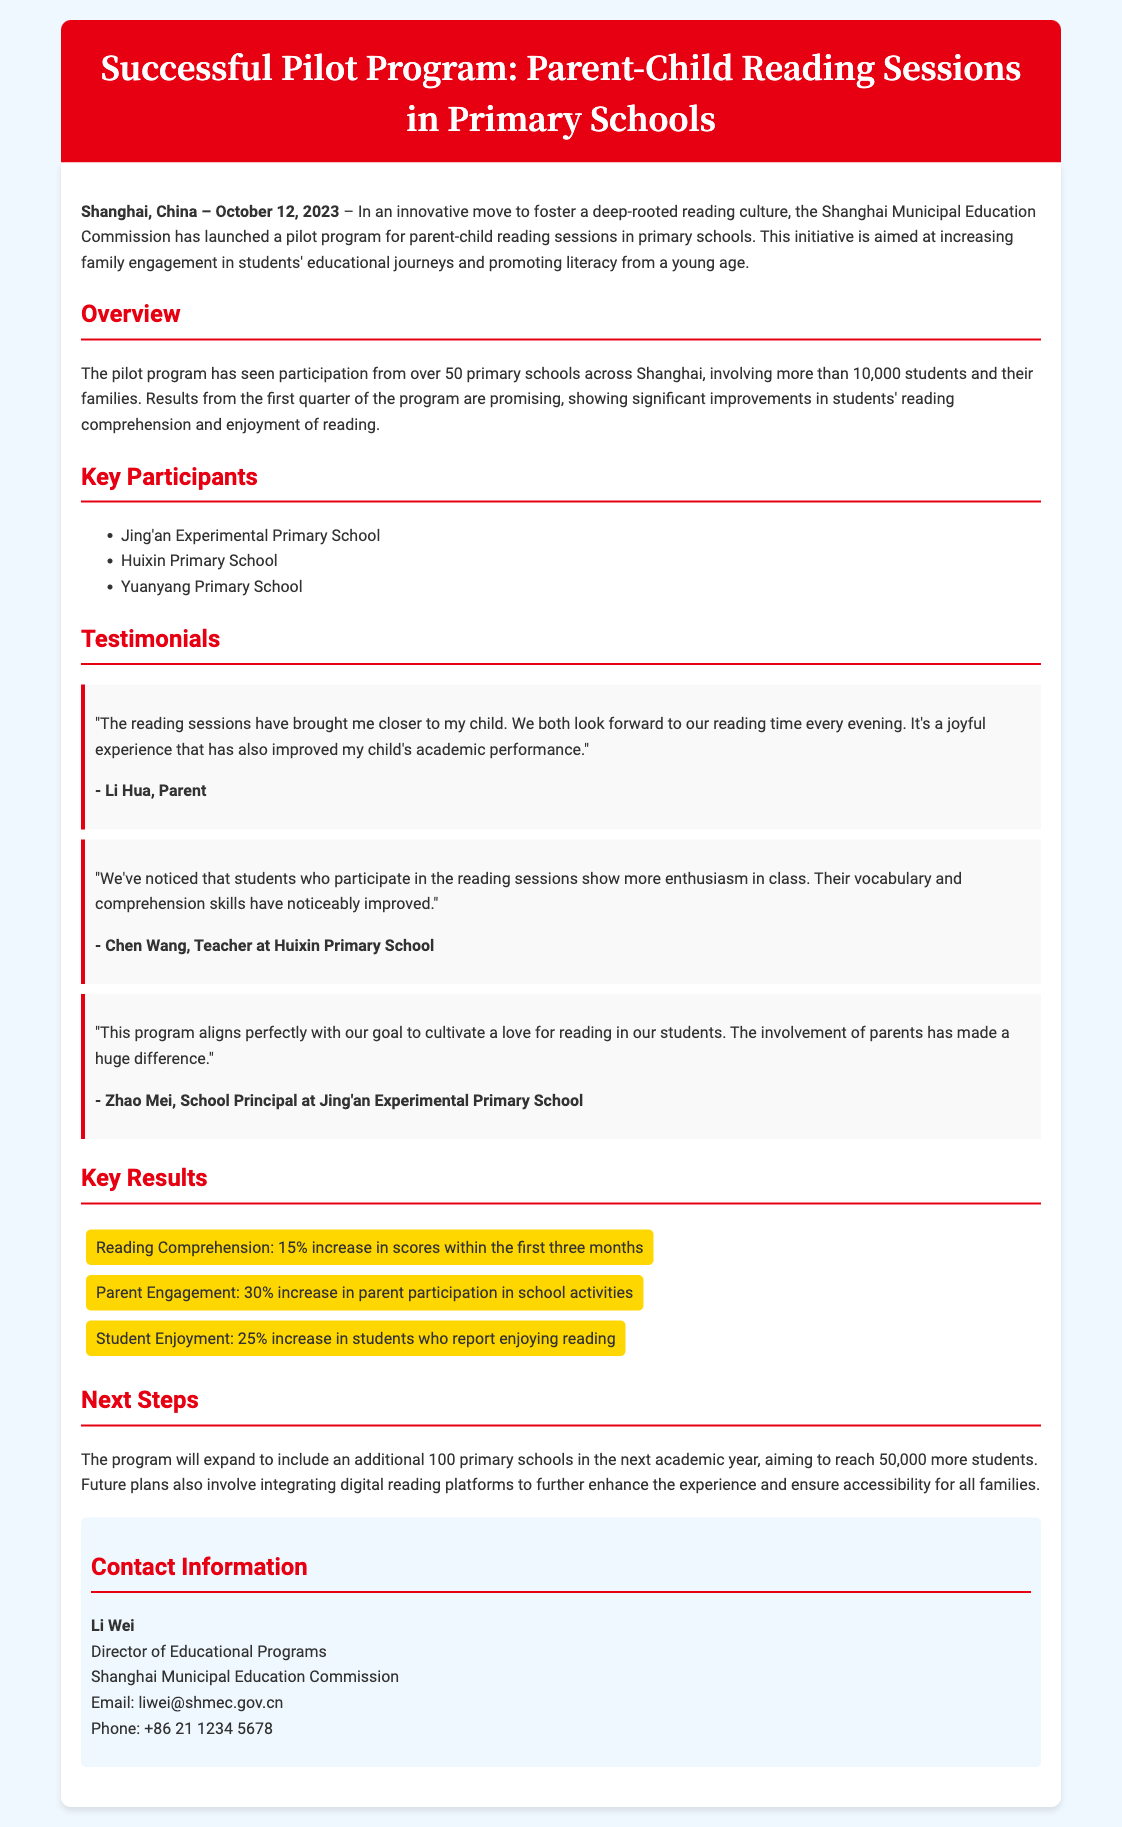What is the launch date of the program? The launch date mentioned in the document is October 12, 2023.
Answer: October 12, 2023 How many primary schools participated in the pilot program? The document states that over 50 primary schools across Shanghai participated in the pilot program.
Answer: Over 50 What percentage increase in reading comprehension was reported within the first three months? The document indicates that there was a 15% increase in reading comprehension scores within the first three months.
Answer: 15% Who is the director of educational programs at the Shanghai Municipal Education Commission? The document lists Li Wei as the Director of Educational Programs.
Answer: Li Wei Which school principal is quoted in the testimonials? The testimonials include a quote from Zhao Mei, the School Principal at Jing'an Experimental Primary School.
Answer: Zhao Mei What is the anticipated reach of the expanded program in the next academic year? The document states that the program aims to reach 50,000 more students in the next academic year.
Answer: 50,000 What notable improvement was reported in student enjoyment of reading? The document mentions a 25% increase in students who report enjoying reading.
Answer: 25% How many students and their families are involved in the program? The document states that more than 10,000 students and their families are involved in the pilot program.
Answer: More than 10,000 